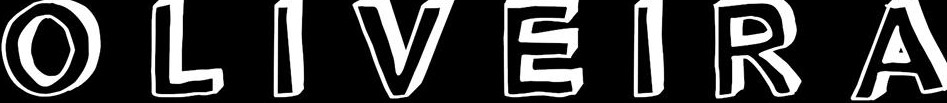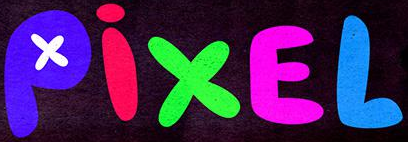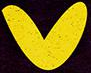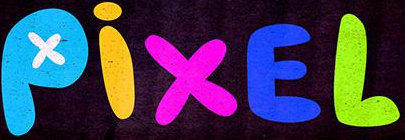Read the text content from these images in order, separated by a semicolon. OLIVEIRA; PixEL; v; PixEL 